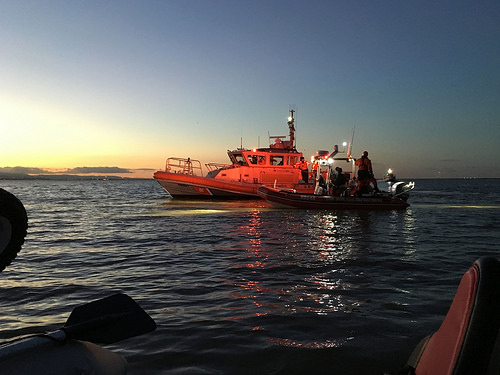<image>
Is there a boat on the boat? No. The boat is not positioned on the boat. They may be near each other, but the boat is not supported by or resting on top of the boat. Is there a water on the boat? No. The water is not positioned on the boat. They may be near each other, but the water is not supported by or resting on top of the boat. 